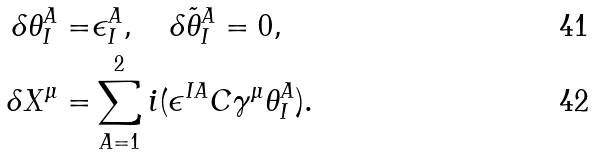Convert formula to latex. <formula><loc_0><loc_0><loc_500><loc_500>\delta \theta ^ { A } _ { I } = & \epsilon ^ { A } _ { I } , \quad \delta \tilde { \theta } ^ { A } _ { I } = 0 , \\ \delta X ^ { \mu } = & \sum _ { A = 1 } ^ { 2 } i ( \epsilon ^ { I A } C \gamma ^ { \mu } \theta ^ { A } _ { I } ) .</formula> 